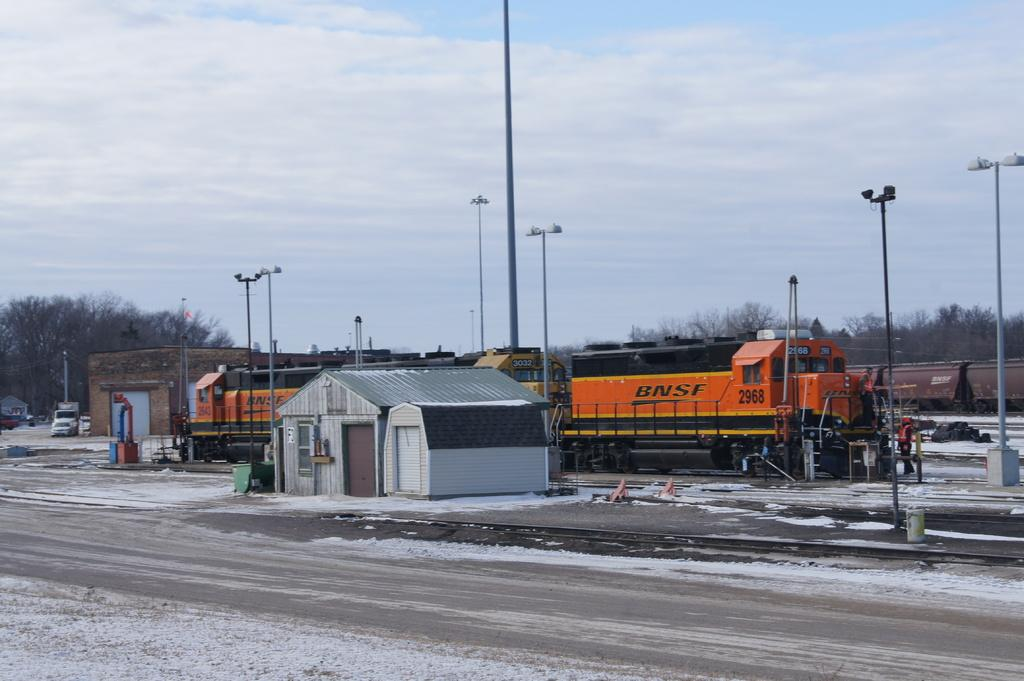<image>
Relay a brief, clear account of the picture shown. A BNSF train sits on a track in the snow. 